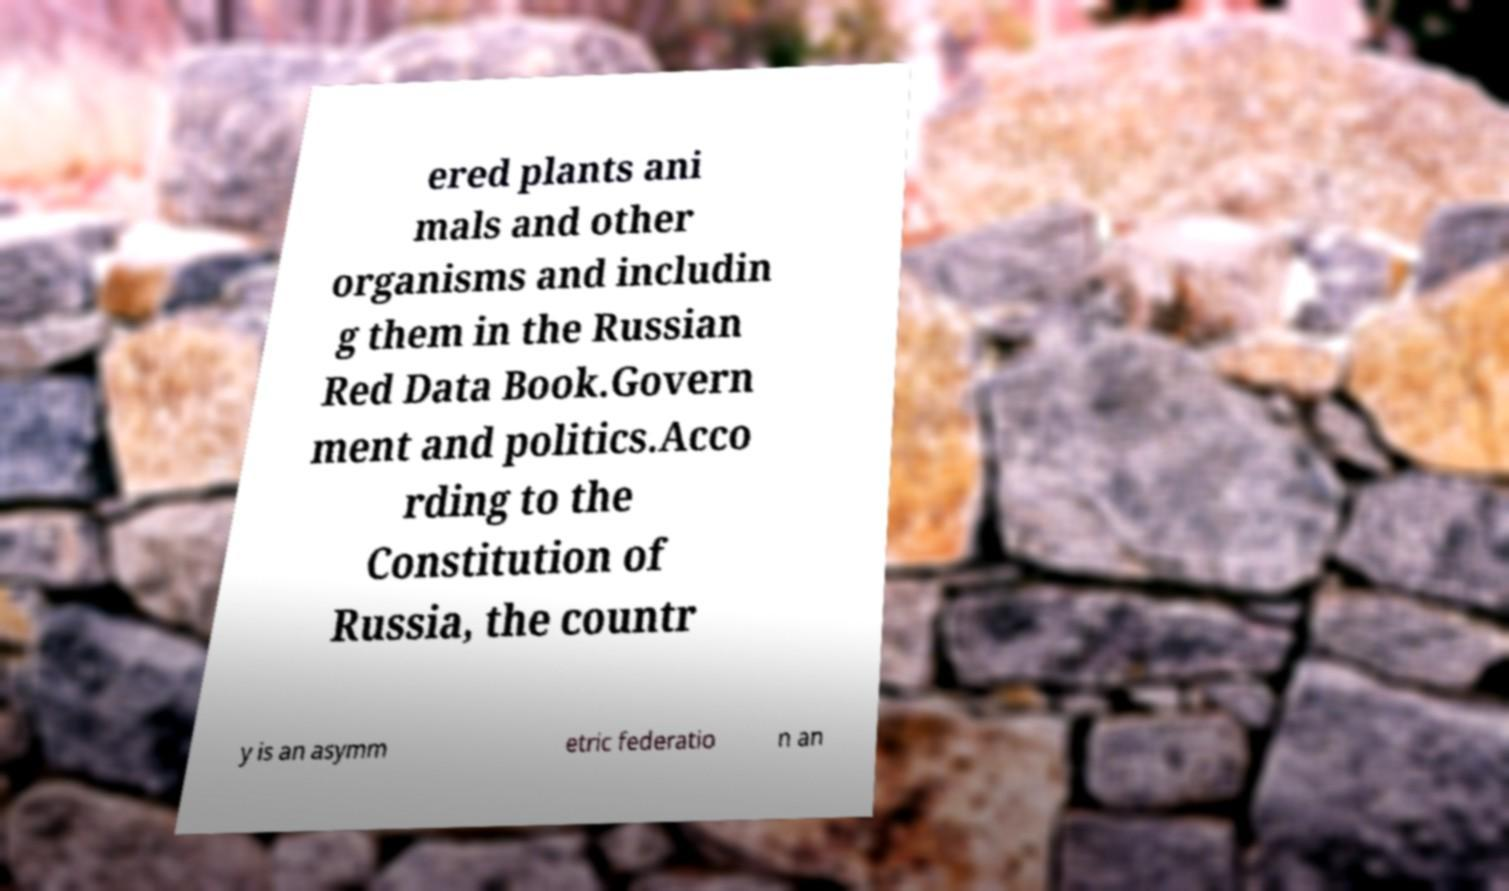Please read and relay the text visible in this image. What does it say? ered plants ani mals and other organisms and includin g them in the Russian Red Data Book.Govern ment and politics.Acco rding to the Constitution of Russia, the countr y is an asymm etric federatio n an 